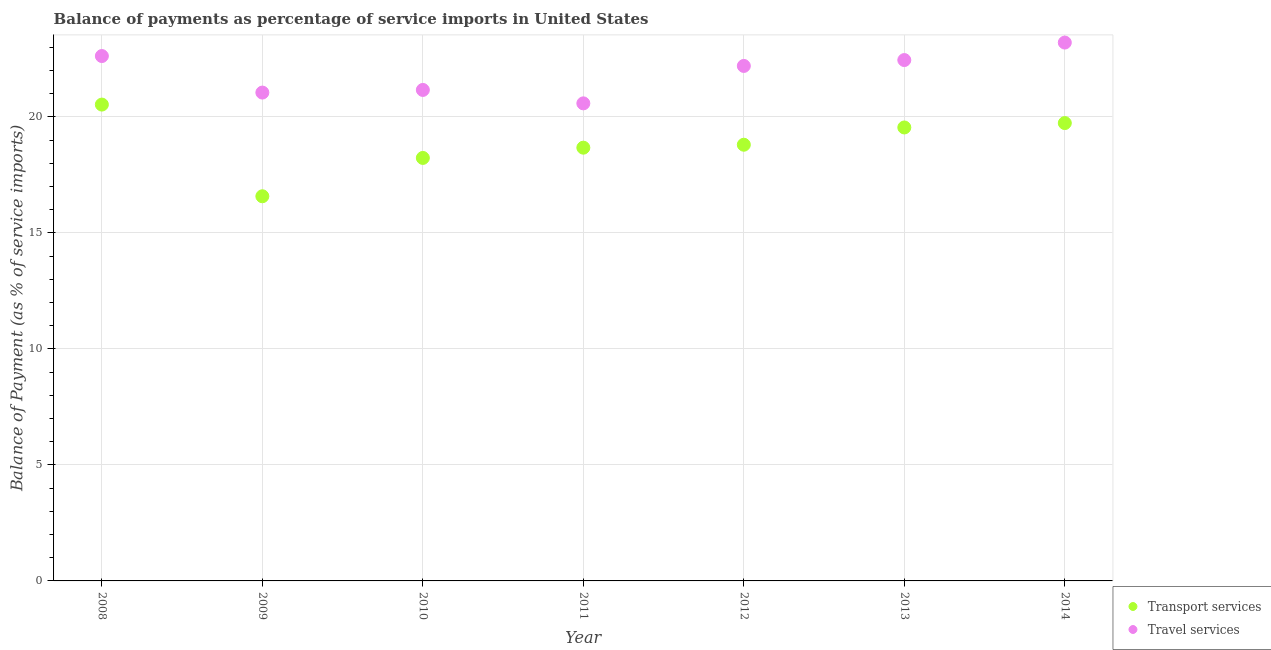What is the balance of payments of transport services in 2011?
Your answer should be very brief. 18.67. Across all years, what is the maximum balance of payments of transport services?
Provide a succinct answer. 20.53. Across all years, what is the minimum balance of payments of transport services?
Keep it short and to the point. 16.58. What is the total balance of payments of travel services in the graph?
Make the answer very short. 153.28. What is the difference between the balance of payments of transport services in 2010 and that in 2011?
Your answer should be very brief. -0.44. What is the difference between the balance of payments of transport services in 2010 and the balance of payments of travel services in 2013?
Provide a succinct answer. -4.22. What is the average balance of payments of transport services per year?
Your response must be concise. 18.87. In the year 2014, what is the difference between the balance of payments of travel services and balance of payments of transport services?
Keep it short and to the point. 3.47. What is the ratio of the balance of payments of transport services in 2011 to that in 2012?
Your answer should be compact. 0.99. Is the balance of payments of travel services in 2008 less than that in 2012?
Offer a terse response. No. What is the difference between the highest and the second highest balance of payments of transport services?
Make the answer very short. 0.8. What is the difference between the highest and the lowest balance of payments of transport services?
Your answer should be compact. 3.95. In how many years, is the balance of payments of travel services greater than the average balance of payments of travel services taken over all years?
Offer a terse response. 4. Does the balance of payments of transport services monotonically increase over the years?
Provide a succinct answer. No. Is the balance of payments of transport services strictly less than the balance of payments of travel services over the years?
Give a very brief answer. Yes. How many years are there in the graph?
Give a very brief answer. 7. Does the graph contain any zero values?
Offer a terse response. No. Does the graph contain grids?
Give a very brief answer. Yes. How many legend labels are there?
Make the answer very short. 2. What is the title of the graph?
Your response must be concise. Balance of payments as percentage of service imports in United States. What is the label or title of the Y-axis?
Offer a terse response. Balance of Payment (as % of service imports). What is the Balance of Payment (as % of service imports) of Transport services in 2008?
Your answer should be very brief. 20.53. What is the Balance of Payment (as % of service imports) in Travel services in 2008?
Keep it short and to the point. 22.62. What is the Balance of Payment (as % of service imports) of Transport services in 2009?
Provide a short and direct response. 16.58. What is the Balance of Payment (as % of service imports) of Travel services in 2009?
Provide a succinct answer. 21.05. What is the Balance of Payment (as % of service imports) in Transport services in 2010?
Offer a very short reply. 18.23. What is the Balance of Payment (as % of service imports) in Travel services in 2010?
Keep it short and to the point. 21.16. What is the Balance of Payment (as % of service imports) in Transport services in 2011?
Your answer should be compact. 18.67. What is the Balance of Payment (as % of service imports) of Travel services in 2011?
Give a very brief answer. 20.58. What is the Balance of Payment (as % of service imports) of Transport services in 2012?
Give a very brief answer. 18.8. What is the Balance of Payment (as % of service imports) of Travel services in 2012?
Provide a short and direct response. 22.2. What is the Balance of Payment (as % of service imports) in Transport services in 2013?
Ensure brevity in your answer.  19.55. What is the Balance of Payment (as % of service imports) in Travel services in 2013?
Make the answer very short. 22.45. What is the Balance of Payment (as % of service imports) in Transport services in 2014?
Your answer should be compact. 19.73. What is the Balance of Payment (as % of service imports) in Travel services in 2014?
Your response must be concise. 23.21. Across all years, what is the maximum Balance of Payment (as % of service imports) of Transport services?
Ensure brevity in your answer.  20.53. Across all years, what is the maximum Balance of Payment (as % of service imports) of Travel services?
Provide a short and direct response. 23.21. Across all years, what is the minimum Balance of Payment (as % of service imports) of Transport services?
Provide a short and direct response. 16.58. Across all years, what is the minimum Balance of Payment (as % of service imports) in Travel services?
Make the answer very short. 20.58. What is the total Balance of Payment (as % of service imports) in Transport services in the graph?
Ensure brevity in your answer.  132.1. What is the total Balance of Payment (as % of service imports) in Travel services in the graph?
Give a very brief answer. 153.28. What is the difference between the Balance of Payment (as % of service imports) in Transport services in 2008 and that in 2009?
Make the answer very short. 3.95. What is the difference between the Balance of Payment (as % of service imports) of Travel services in 2008 and that in 2009?
Offer a terse response. 1.57. What is the difference between the Balance of Payment (as % of service imports) in Transport services in 2008 and that in 2010?
Your answer should be compact. 2.3. What is the difference between the Balance of Payment (as % of service imports) in Travel services in 2008 and that in 2010?
Ensure brevity in your answer.  1.46. What is the difference between the Balance of Payment (as % of service imports) of Transport services in 2008 and that in 2011?
Provide a short and direct response. 1.86. What is the difference between the Balance of Payment (as % of service imports) in Travel services in 2008 and that in 2011?
Give a very brief answer. 2.04. What is the difference between the Balance of Payment (as % of service imports) of Transport services in 2008 and that in 2012?
Your response must be concise. 1.73. What is the difference between the Balance of Payment (as % of service imports) in Travel services in 2008 and that in 2012?
Ensure brevity in your answer.  0.43. What is the difference between the Balance of Payment (as % of service imports) in Transport services in 2008 and that in 2013?
Ensure brevity in your answer.  0.99. What is the difference between the Balance of Payment (as % of service imports) in Travel services in 2008 and that in 2013?
Give a very brief answer. 0.17. What is the difference between the Balance of Payment (as % of service imports) in Transport services in 2008 and that in 2014?
Provide a succinct answer. 0.8. What is the difference between the Balance of Payment (as % of service imports) of Travel services in 2008 and that in 2014?
Provide a succinct answer. -0.58. What is the difference between the Balance of Payment (as % of service imports) in Transport services in 2009 and that in 2010?
Offer a terse response. -1.65. What is the difference between the Balance of Payment (as % of service imports) of Travel services in 2009 and that in 2010?
Your response must be concise. -0.11. What is the difference between the Balance of Payment (as % of service imports) of Transport services in 2009 and that in 2011?
Give a very brief answer. -2.09. What is the difference between the Balance of Payment (as % of service imports) of Travel services in 2009 and that in 2011?
Give a very brief answer. 0.47. What is the difference between the Balance of Payment (as % of service imports) of Transport services in 2009 and that in 2012?
Provide a short and direct response. -2.22. What is the difference between the Balance of Payment (as % of service imports) of Travel services in 2009 and that in 2012?
Ensure brevity in your answer.  -1.15. What is the difference between the Balance of Payment (as % of service imports) in Transport services in 2009 and that in 2013?
Provide a short and direct response. -2.97. What is the difference between the Balance of Payment (as % of service imports) in Travel services in 2009 and that in 2013?
Provide a succinct answer. -1.4. What is the difference between the Balance of Payment (as % of service imports) in Transport services in 2009 and that in 2014?
Provide a short and direct response. -3.15. What is the difference between the Balance of Payment (as % of service imports) in Travel services in 2009 and that in 2014?
Your answer should be compact. -2.16. What is the difference between the Balance of Payment (as % of service imports) in Transport services in 2010 and that in 2011?
Provide a short and direct response. -0.44. What is the difference between the Balance of Payment (as % of service imports) in Travel services in 2010 and that in 2011?
Offer a terse response. 0.58. What is the difference between the Balance of Payment (as % of service imports) in Transport services in 2010 and that in 2012?
Your answer should be compact. -0.57. What is the difference between the Balance of Payment (as % of service imports) in Travel services in 2010 and that in 2012?
Offer a terse response. -1.03. What is the difference between the Balance of Payment (as % of service imports) in Transport services in 2010 and that in 2013?
Make the answer very short. -1.31. What is the difference between the Balance of Payment (as % of service imports) in Travel services in 2010 and that in 2013?
Make the answer very short. -1.29. What is the difference between the Balance of Payment (as % of service imports) in Transport services in 2010 and that in 2014?
Give a very brief answer. -1.5. What is the difference between the Balance of Payment (as % of service imports) in Travel services in 2010 and that in 2014?
Your answer should be compact. -2.04. What is the difference between the Balance of Payment (as % of service imports) in Transport services in 2011 and that in 2012?
Offer a very short reply. -0.13. What is the difference between the Balance of Payment (as % of service imports) of Travel services in 2011 and that in 2012?
Offer a terse response. -1.61. What is the difference between the Balance of Payment (as % of service imports) in Transport services in 2011 and that in 2013?
Offer a terse response. -0.87. What is the difference between the Balance of Payment (as % of service imports) in Travel services in 2011 and that in 2013?
Offer a terse response. -1.87. What is the difference between the Balance of Payment (as % of service imports) in Transport services in 2011 and that in 2014?
Offer a very short reply. -1.06. What is the difference between the Balance of Payment (as % of service imports) in Travel services in 2011 and that in 2014?
Make the answer very short. -2.62. What is the difference between the Balance of Payment (as % of service imports) in Transport services in 2012 and that in 2013?
Keep it short and to the point. -0.74. What is the difference between the Balance of Payment (as % of service imports) in Travel services in 2012 and that in 2013?
Offer a terse response. -0.25. What is the difference between the Balance of Payment (as % of service imports) of Transport services in 2012 and that in 2014?
Offer a terse response. -0.93. What is the difference between the Balance of Payment (as % of service imports) of Travel services in 2012 and that in 2014?
Give a very brief answer. -1.01. What is the difference between the Balance of Payment (as % of service imports) of Transport services in 2013 and that in 2014?
Your answer should be very brief. -0.19. What is the difference between the Balance of Payment (as % of service imports) of Travel services in 2013 and that in 2014?
Your answer should be very brief. -0.75. What is the difference between the Balance of Payment (as % of service imports) of Transport services in 2008 and the Balance of Payment (as % of service imports) of Travel services in 2009?
Your answer should be compact. -0.52. What is the difference between the Balance of Payment (as % of service imports) of Transport services in 2008 and the Balance of Payment (as % of service imports) of Travel services in 2010?
Offer a very short reply. -0.63. What is the difference between the Balance of Payment (as % of service imports) in Transport services in 2008 and the Balance of Payment (as % of service imports) in Travel services in 2011?
Offer a very short reply. -0.05. What is the difference between the Balance of Payment (as % of service imports) of Transport services in 2008 and the Balance of Payment (as % of service imports) of Travel services in 2012?
Provide a short and direct response. -1.67. What is the difference between the Balance of Payment (as % of service imports) of Transport services in 2008 and the Balance of Payment (as % of service imports) of Travel services in 2013?
Your answer should be very brief. -1.92. What is the difference between the Balance of Payment (as % of service imports) in Transport services in 2008 and the Balance of Payment (as % of service imports) in Travel services in 2014?
Your response must be concise. -2.67. What is the difference between the Balance of Payment (as % of service imports) in Transport services in 2009 and the Balance of Payment (as % of service imports) in Travel services in 2010?
Your response must be concise. -4.58. What is the difference between the Balance of Payment (as % of service imports) of Transport services in 2009 and the Balance of Payment (as % of service imports) of Travel services in 2011?
Keep it short and to the point. -4. What is the difference between the Balance of Payment (as % of service imports) of Transport services in 2009 and the Balance of Payment (as % of service imports) of Travel services in 2012?
Give a very brief answer. -5.62. What is the difference between the Balance of Payment (as % of service imports) in Transport services in 2009 and the Balance of Payment (as % of service imports) in Travel services in 2013?
Provide a short and direct response. -5.87. What is the difference between the Balance of Payment (as % of service imports) of Transport services in 2009 and the Balance of Payment (as % of service imports) of Travel services in 2014?
Offer a terse response. -6.63. What is the difference between the Balance of Payment (as % of service imports) of Transport services in 2010 and the Balance of Payment (as % of service imports) of Travel services in 2011?
Provide a succinct answer. -2.35. What is the difference between the Balance of Payment (as % of service imports) in Transport services in 2010 and the Balance of Payment (as % of service imports) in Travel services in 2012?
Make the answer very short. -3.97. What is the difference between the Balance of Payment (as % of service imports) in Transport services in 2010 and the Balance of Payment (as % of service imports) in Travel services in 2013?
Provide a succinct answer. -4.22. What is the difference between the Balance of Payment (as % of service imports) in Transport services in 2010 and the Balance of Payment (as % of service imports) in Travel services in 2014?
Provide a succinct answer. -4.97. What is the difference between the Balance of Payment (as % of service imports) of Transport services in 2011 and the Balance of Payment (as % of service imports) of Travel services in 2012?
Give a very brief answer. -3.52. What is the difference between the Balance of Payment (as % of service imports) in Transport services in 2011 and the Balance of Payment (as % of service imports) in Travel services in 2013?
Keep it short and to the point. -3.78. What is the difference between the Balance of Payment (as % of service imports) of Transport services in 2011 and the Balance of Payment (as % of service imports) of Travel services in 2014?
Offer a very short reply. -4.53. What is the difference between the Balance of Payment (as % of service imports) of Transport services in 2012 and the Balance of Payment (as % of service imports) of Travel services in 2013?
Provide a succinct answer. -3.65. What is the difference between the Balance of Payment (as % of service imports) in Transport services in 2012 and the Balance of Payment (as % of service imports) in Travel services in 2014?
Provide a succinct answer. -4.4. What is the difference between the Balance of Payment (as % of service imports) in Transport services in 2013 and the Balance of Payment (as % of service imports) in Travel services in 2014?
Your response must be concise. -3.66. What is the average Balance of Payment (as % of service imports) of Transport services per year?
Provide a succinct answer. 18.87. What is the average Balance of Payment (as % of service imports) of Travel services per year?
Provide a short and direct response. 21.9. In the year 2008, what is the difference between the Balance of Payment (as % of service imports) of Transport services and Balance of Payment (as % of service imports) of Travel services?
Make the answer very short. -2.09. In the year 2009, what is the difference between the Balance of Payment (as % of service imports) of Transport services and Balance of Payment (as % of service imports) of Travel services?
Provide a short and direct response. -4.47. In the year 2010, what is the difference between the Balance of Payment (as % of service imports) in Transport services and Balance of Payment (as % of service imports) in Travel services?
Ensure brevity in your answer.  -2.93. In the year 2011, what is the difference between the Balance of Payment (as % of service imports) in Transport services and Balance of Payment (as % of service imports) in Travel services?
Offer a very short reply. -1.91. In the year 2012, what is the difference between the Balance of Payment (as % of service imports) in Transport services and Balance of Payment (as % of service imports) in Travel services?
Your response must be concise. -3.4. In the year 2013, what is the difference between the Balance of Payment (as % of service imports) in Transport services and Balance of Payment (as % of service imports) in Travel services?
Provide a succinct answer. -2.91. In the year 2014, what is the difference between the Balance of Payment (as % of service imports) of Transport services and Balance of Payment (as % of service imports) of Travel services?
Offer a terse response. -3.47. What is the ratio of the Balance of Payment (as % of service imports) of Transport services in 2008 to that in 2009?
Give a very brief answer. 1.24. What is the ratio of the Balance of Payment (as % of service imports) of Travel services in 2008 to that in 2009?
Offer a terse response. 1.07. What is the ratio of the Balance of Payment (as % of service imports) in Transport services in 2008 to that in 2010?
Make the answer very short. 1.13. What is the ratio of the Balance of Payment (as % of service imports) of Travel services in 2008 to that in 2010?
Your answer should be very brief. 1.07. What is the ratio of the Balance of Payment (as % of service imports) of Transport services in 2008 to that in 2011?
Your answer should be compact. 1.1. What is the ratio of the Balance of Payment (as % of service imports) of Travel services in 2008 to that in 2011?
Your response must be concise. 1.1. What is the ratio of the Balance of Payment (as % of service imports) of Transport services in 2008 to that in 2012?
Provide a short and direct response. 1.09. What is the ratio of the Balance of Payment (as % of service imports) in Travel services in 2008 to that in 2012?
Make the answer very short. 1.02. What is the ratio of the Balance of Payment (as % of service imports) in Transport services in 2008 to that in 2013?
Provide a short and direct response. 1.05. What is the ratio of the Balance of Payment (as % of service imports) in Travel services in 2008 to that in 2013?
Provide a succinct answer. 1.01. What is the ratio of the Balance of Payment (as % of service imports) of Transport services in 2008 to that in 2014?
Ensure brevity in your answer.  1.04. What is the ratio of the Balance of Payment (as % of service imports) of Transport services in 2009 to that in 2010?
Offer a very short reply. 0.91. What is the ratio of the Balance of Payment (as % of service imports) of Travel services in 2009 to that in 2010?
Offer a very short reply. 0.99. What is the ratio of the Balance of Payment (as % of service imports) in Transport services in 2009 to that in 2011?
Make the answer very short. 0.89. What is the ratio of the Balance of Payment (as % of service imports) in Travel services in 2009 to that in 2011?
Your response must be concise. 1.02. What is the ratio of the Balance of Payment (as % of service imports) of Transport services in 2009 to that in 2012?
Offer a very short reply. 0.88. What is the ratio of the Balance of Payment (as % of service imports) of Travel services in 2009 to that in 2012?
Ensure brevity in your answer.  0.95. What is the ratio of the Balance of Payment (as % of service imports) in Transport services in 2009 to that in 2013?
Give a very brief answer. 0.85. What is the ratio of the Balance of Payment (as % of service imports) in Travel services in 2009 to that in 2013?
Your response must be concise. 0.94. What is the ratio of the Balance of Payment (as % of service imports) of Transport services in 2009 to that in 2014?
Keep it short and to the point. 0.84. What is the ratio of the Balance of Payment (as % of service imports) in Travel services in 2009 to that in 2014?
Keep it short and to the point. 0.91. What is the ratio of the Balance of Payment (as % of service imports) of Transport services in 2010 to that in 2011?
Keep it short and to the point. 0.98. What is the ratio of the Balance of Payment (as % of service imports) in Travel services in 2010 to that in 2011?
Offer a very short reply. 1.03. What is the ratio of the Balance of Payment (as % of service imports) in Transport services in 2010 to that in 2012?
Keep it short and to the point. 0.97. What is the ratio of the Balance of Payment (as % of service imports) in Travel services in 2010 to that in 2012?
Make the answer very short. 0.95. What is the ratio of the Balance of Payment (as % of service imports) in Transport services in 2010 to that in 2013?
Ensure brevity in your answer.  0.93. What is the ratio of the Balance of Payment (as % of service imports) of Travel services in 2010 to that in 2013?
Make the answer very short. 0.94. What is the ratio of the Balance of Payment (as % of service imports) of Transport services in 2010 to that in 2014?
Ensure brevity in your answer.  0.92. What is the ratio of the Balance of Payment (as % of service imports) in Travel services in 2010 to that in 2014?
Provide a short and direct response. 0.91. What is the ratio of the Balance of Payment (as % of service imports) in Travel services in 2011 to that in 2012?
Give a very brief answer. 0.93. What is the ratio of the Balance of Payment (as % of service imports) of Transport services in 2011 to that in 2013?
Provide a succinct answer. 0.96. What is the ratio of the Balance of Payment (as % of service imports) in Travel services in 2011 to that in 2013?
Offer a very short reply. 0.92. What is the ratio of the Balance of Payment (as % of service imports) in Transport services in 2011 to that in 2014?
Ensure brevity in your answer.  0.95. What is the ratio of the Balance of Payment (as % of service imports) in Travel services in 2011 to that in 2014?
Offer a very short reply. 0.89. What is the ratio of the Balance of Payment (as % of service imports) of Transport services in 2012 to that in 2013?
Provide a succinct answer. 0.96. What is the ratio of the Balance of Payment (as % of service imports) in Travel services in 2012 to that in 2013?
Make the answer very short. 0.99. What is the ratio of the Balance of Payment (as % of service imports) of Transport services in 2012 to that in 2014?
Offer a very short reply. 0.95. What is the ratio of the Balance of Payment (as % of service imports) in Travel services in 2012 to that in 2014?
Keep it short and to the point. 0.96. What is the ratio of the Balance of Payment (as % of service imports) of Travel services in 2013 to that in 2014?
Your response must be concise. 0.97. What is the difference between the highest and the second highest Balance of Payment (as % of service imports) in Transport services?
Offer a terse response. 0.8. What is the difference between the highest and the second highest Balance of Payment (as % of service imports) of Travel services?
Offer a very short reply. 0.58. What is the difference between the highest and the lowest Balance of Payment (as % of service imports) of Transport services?
Your answer should be very brief. 3.95. What is the difference between the highest and the lowest Balance of Payment (as % of service imports) of Travel services?
Make the answer very short. 2.62. 